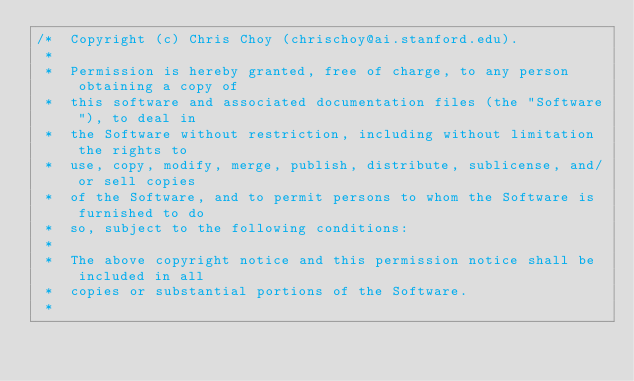<code> <loc_0><loc_0><loc_500><loc_500><_Cuda_>/*  Copyright (c) Chris Choy (chrischoy@ai.stanford.edu).
 *
 *  Permission is hereby granted, free of charge, to any person obtaining a copy of
 *  this software and associated documentation files (the "Software"), to deal in
 *  the Software without restriction, including without limitation the rights to
 *  use, copy, modify, merge, publish, distribute, sublicense, and/or sell copies
 *  of the Software, and to permit persons to whom the Software is furnished to do
 *  so, subject to the following conditions:
 *
 *  The above copyright notice and this permission notice shall be included in all
 *  copies or substantial portions of the Software.
 *</code> 